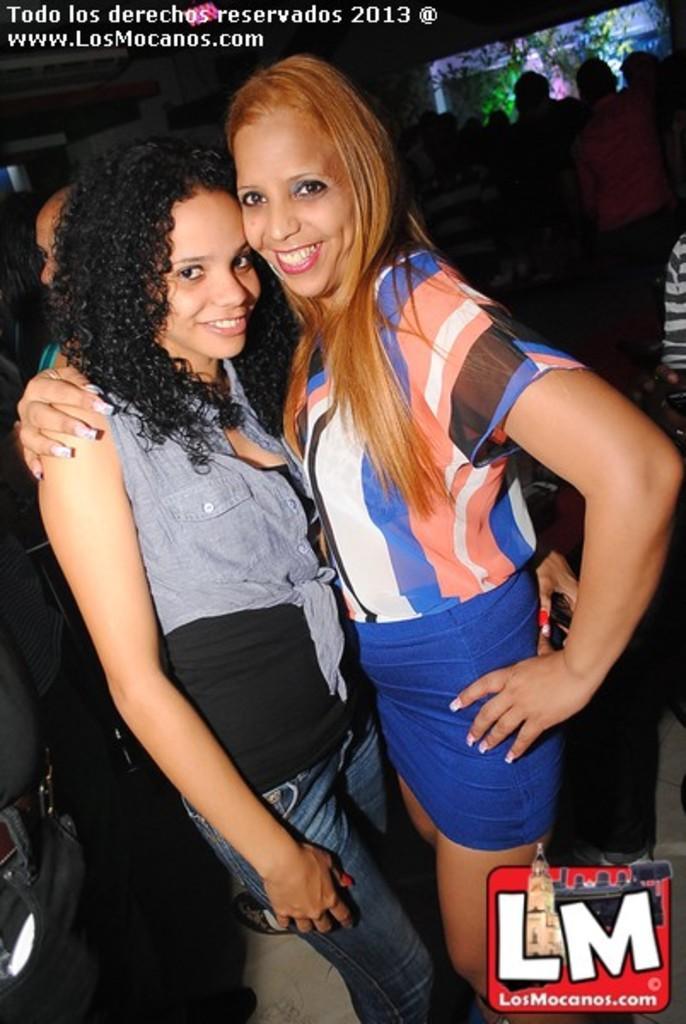How would you summarize this image in a sentence or two? In the picture I can see a group of people are standing on the ground. I can also see something written on the image. 